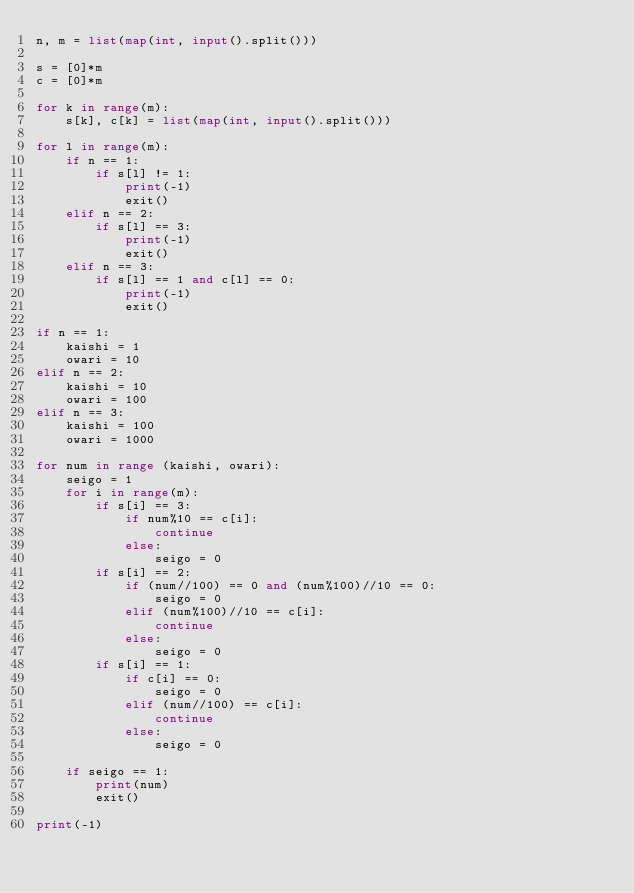<code> <loc_0><loc_0><loc_500><loc_500><_Python_>n, m = list(map(int, input().split()))

s = [0]*m
c = [0]*m

for k in range(m):
    s[k], c[k] = list(map(int, input().split()))

for l in range(m):
    if n == 1:
        if s[l] != 1:
            print(-1)
            exit()
    elif n == 2:
        if s[l] == 3:
            print(-1)
            exit()
    elif n == 3:
        if s[l] == 1 and c[l] == 0:
            print(-1)
            exit()

if n == 1:
    kaishi = 1
    owari = 10
elif n == 2:
    kaishi = 10
    owari = 100
elif n == 3:
    kaishi = 100
    owari = 1000

for num in range (kaishi, owari):
    seigo = 1
    for i in range(m):
        if s[i] == 3:
            if num%10 == c[i]:
                continue
            else:
                seigo = 0
        if s[i] == 2:
            if (num//100) == 0 and (num%100)//10 == 0:
                seigo = 0 
            elif (num%100)//10 == c[i]:
                continue
            else:
                seigo = 0
        if s[i] == 1:
            if c[i] == 0:
                seigo = 0
            elif (num//100) == c[i]:
                continue
            else:
                seigo = 0

    if seigo == 1:
        print(num)
        exit()
        
print(-1)



</code> 